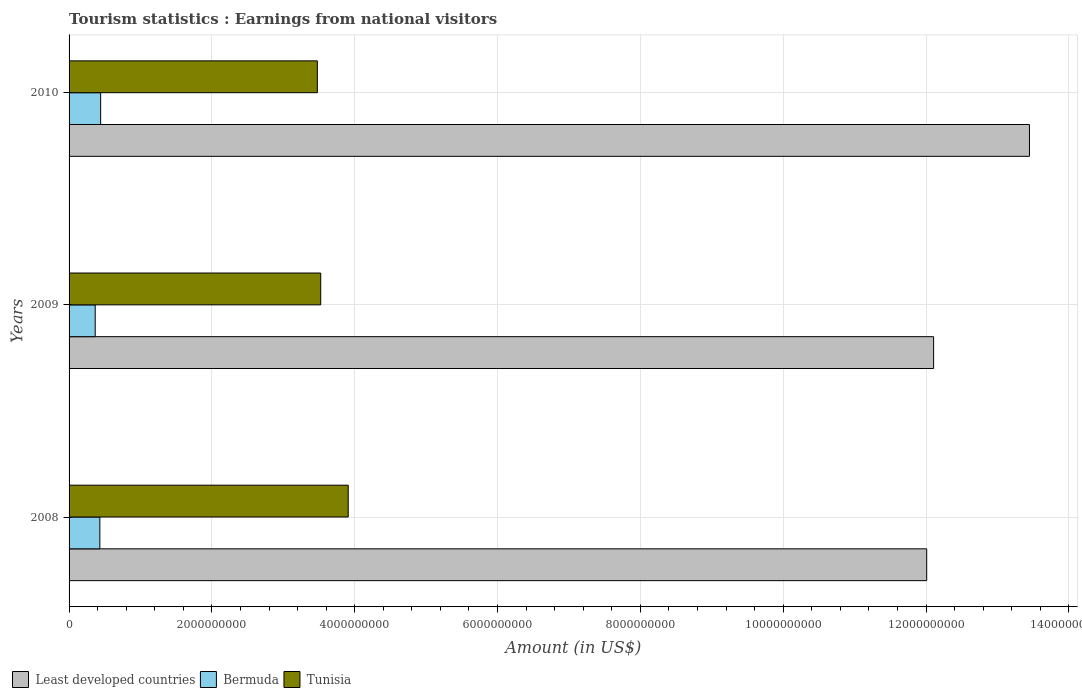What is the label of the 2nd group of bars from the top?
Your response must be concise. 2009. In how many cases, is the number of bars for a given year not equal to the number of legend labels?
Provide a short and direct response. 0. What is the earnings from national visitors in Tunisia in 2008?
Give a very brief answer. 3.91e+09. Across all years, what is the maximum earnings from national visitors in Bermuda?
Provide a succinct answer. 4.42e+08. Across all years, what is the minimum earnings from national visitors in Least developed countries?
Keep it short and to the point. 1.20e+1. In which year was the earnings from national visitors in Tunisia maximum?
Keep it short and to the point. 2008. In which year was the earnings from national visitors in Tunisia minimum?
Make the answer very short. 2010. What is the total earnings from national visitors in Bermuda in the graph?
Provide a short and direct response. 1.24e+09. What is the difference between the earnings from national visitors in Least developed countries in 2009 and that in 2010?
Give a very brief answer. -1.34e+09. What is the difference between the earnings from national visitors in Least developed countries in 2009 and the earnings from national visitors in Bermuda in 2008?
Offer a very short reply. 1.17e+1. What is the average earnings from national visitors in Bermuda per year?
Give a very brief answer. 4.13e+08. In the year 2008, what is the difference between the earnings from national visitors in Bermuda and earnings from national visitors in Least developed countries?
Keep it short and to the point. -1.16e+1. What is the ratio of the earnings from national visitors in Least developed countries in 2008 to that in 2010?
Offer a terse response. 0.89. Is the difference between the earnings from national visitors in Bermuda in 2008 and 2009 greater than the difference between the earnings from national visitors in Least developed countries in 2008 and 2009?
Keep it short and to the point. Yes. What is the difference between the highest and the second highest earnings from national visitors in Tunisia?
Make the answer very short. 3.85e+08. What is the difference between the highest and the lowest earnings from national visitors in Bermuda?
Your answer should be very brief. 7.60e+07. What does the 2nd bar from the top in 2009 represents?
Your answer should be very brief. Bermuda. What does the 2nd bar from the bottom in 2009 represents?
Your answer should be compact. Bermuda. Is it the case that in every year, the sum of the earnings from national visitors in Tunisia and earnings from national visitors in Bermuda is greater than the earnings from national visitors in Least developed countries?
Give a very brief answer. No. Are all the bars in the graph horizontal?
Your response must be concise. Yes. What is the difference between two consecutive major ticks on the X-axis?
Ensure brevity in your answer.  2.00e+09. Does the graph contain grids?
Offer a very short reply. Yes. How many legend labels are there?
Your answer should be very brief. 3. What is the title of the graph?
Provide a succinct answer. Tourism statistics : Earnings from national visitors. What is the label or title of the X-axis?
Give a very brief answer. Amount (in US$). What is the Amount (in US$) in Least developed countries in 2008?
Your response must be concise. 1.20e+1. What is the Amount (in US$) of Bermuda in 2008?
Your response must be concise. 4.31e+08. What is the Amount (in US$) of Tunisia in 2008?
Provide a short and direct response. 3.91e+09. What is the Amount (in US$) of Least developed countries in 2009?
Give a very brief answer. 1.21e+1. What is the Amount (in US$) of Bermuda in 2009?
Your answer should be compact. 3.66e+08. What is the Amount (in US$) of Tunisia in 2009?
Keep it short and to the point. 3.52e+09. What is the Amount (in US$) in Least developed countries in 2010?
Make the answer very short. 1.34e+1. What is the Amount (in US$) of Bermuda in 2010?
Offer a terse response. 4.42e+08. What is the Amount (in US$) in Tunisia in 2010?
Provide a succinct answer. 3.48e+09. Across all years, what is the maximum Amount (in US$) in Least developed countries?
Give a very brief answer. 1.34e+1. Across all years, what is the maximum Amount (in US$) in Bermuda?
Your response must be concise. 4.42e+08. Across all years, what is the maximum Amount (in US$) in Tunisia?
Provide a short and direct response. 3.91e+09. Across all years, what is the minimum Amount (in US$) of Least developed countries?
Ensure brevity in your answer.  1.20e+1. Across all years, what is the minimum Amount (in US$) in Bermuda?
Provide a succinct answer. 3.66e+08. Across all years, what is the minimum Amount (in US$) in Tunisia?
Offer a terse response. 3.48e+09. What is the total Amount (in US$) of Least developed countries in the graph?
Keep it short and to the point. 3.76e+1. What is the total Amount (in US$) in Bermuda in the graph?
Offer a very short reply. 1.24e+09. What is the total Amount (in US$) in Tunisia in the graph?
Provide a succinct answer. 1.09e+1. What is the difference between the Amount (in US$) of Least developed countries in 2008 and that in 2009?
Ensure brevity in your answer.  -9.67e+07. What is the difference between the Amount (in US$) of Bermuda in 2008 and that in 2009?
Provide a succinct answer. 6.50e+07. What is the difference between the Amount (in US$) of Tunisia in 2008 and that in 2009?
Provide a succinct answer. 3.85e+08. What is the difference between the Amount (in US$) of Least developed countries in 2008 and that in 2010?
Ensure brevity in your answer.  -1.44e+09. What is the difference between the Amount (in US$) of Bermuda in 2008 and that in 2010?
Your answer should be very brief. -1.10e+07. What is the difference between the Amount (in US$) of Tunisia in 2008 and that in 2010?
Offer a very short reply. 4.32e+08. What is the difference between the Amount (in US$) of Least developed countries in 2009 and that in 2010?
Your answer should be very brief. -1.34e+09. What is the difference between the Amount (in US$) in Bermuda in 2009 and that in 2010?
Provide a succinct answer. -7.60e+07. What is the difference between the Amount (in US$) of Tunisia in 2009 and that in 2010?
Ensure brevity in your answer.  4.70e+07. What is the difference between the Amount (in US$) of Least developed countries in 2008 and the Amount (in US$) of Bermuda in 2009?
Your answer should be very brief. 1.16e+1. What is the difference between the Amount (in US$) of Least developed countries in 2008 and the Amount (in US$) of Tunisia in 2009?
Offer a terse response. 8.49e+09. What is the difference between the Amount (in US$) of Bermuda in 2008 and the Amount (in US$) of Tunisia in 2009?
Provide a succinct answer. -3.09e+09. What is the difference between the Amount (in US$) in Least developed countries in 2008 and the Amount (in US$) in Bermuda in 2010?
Your answer should be compact. 1.16e+1. What is the difference between the Amount (in US$) of Least developed countries in 2008 and the Amount (in US$) of Tunisia in 2010?
Ensure brevity in your answer.  8.53e+09. What is the difference between the Amount (in US$) of Bermuda in 2008 and the Amount (in US$) of Tunisia in 2010?
Your answer should be compact. -3.05e+09. What is the difference between the Amount (in US$) in Least developed countries in 2009 and the Amount (in US$) in Bermuda in 2010?
Keep it short and to the point. 1.17e+1. What is the difference between the Amount (in US$) in Least developed countries in 2009 and the Amount (in US$) in Tunisia in 2010?
Your response must be concise. 8.63e+09. What is the difference between the Amount (in US$) in Bermuda in 2009 and the Amount (in US$) in Tunisia in 2010?
Offer a terse response. -3.11e+09. What is the average Amount (in US$) of Least developed countries per year?
Provide a short and direct response. 1.25e+1. What is the average Amount (in US$) in Bermuda per year?
Your answer should be very brief. 4.13e+08. What is the average Amount (in US$) in Tunisia per year?
Keep it short and to the point. 3.64e+09. In the year 2008, what is the difference between the Amount (in US$) of Least developed countries and Amount (in US$) of Bermuda?
Your answer should be compact. 1.16e+1. In the year 2008, what is the difference between the Amount (in US$) in Least developed countries and Amount (in US$) in Tunisia?
Make the answer very short. 8.10e+09. In the year 2008, what is the difference between the Amount (in US$) of Bermuda and Amount (in US$) of Tunisia?
Offer a very short reply. -3.48e+09. In the year 2009, what is the difference between the Amount (in US$) in Least developed countries and Amount (in US$) in Bermuda?
Keep it short and to the point. 1.17e+1. In the year 2009, what is the difference between the Amount (in US$) of Least developed countries and Amount (in US$) of Tunisia?
Make the answer very short. 8.58e+09. In the year 2009, what is the difference between the Amount (in US$) of Bermuda and Amount (in US$) of Tunisia?
Your response must be concise. -3.16e+09. In the year 2010, what is the difference between the Amount (in US$) in Least developed countries and Amount (in US$) in Bermuda?
Your answer should be compact. 1.30e+1. In the year 2010, what is the difference between the Amount (in US$) of Least developed countries and Amount (in US$) of Tunisia?
Make the answer very short. 9.97e+09. In the year 2010, what is the difference between the Amount (in US$) of Bermuda and Amount (in US$) of Tunisia?
Make the answer very short. -3.04e+09. What is the ratio of the Amount (in US$) in Bermuda in 2008 to that in 2009?
Ensure brevity in your answer.  1.18. What is the ratio of the Amount (in US$) of Tunisia in 2008 to that in 2009?
Your answer should be very brief. 1.11. What is the ratio of the Amount (in US$) in Least developed countries in 2008 to that in 2010?
Give a very brief answer. 0.89. What is the ratio of the Amount (in US$) of Bermuda in 2008 to that in 2010?
Make the answer very short. 0.98. What is the ratio of the Amount (in US$) in Tunisia in 2008 to that in 2010?
Make the answer very short. 1.12. What is the ratio of the Amount (in US$) of Least developed countries in 2009 to that in 2010?
Your answer should be compact. 0.9. What is the ratio of the Amount (in US$) in Bermuda in 2009 to that in 2010?
Provide a succinct answer. 0.83. What is the ratio of the Amount (in US$) of Tunisia in 2009 to that in 2010?
Your answer should be very brief. 1.01. What is the difference between the highest and the second highest Amount (in US$) in Least developed countries?
Offer a terse response. 1.34e+09. What is the difference between the highest and the second highest Amount (in US$) in Bermuda?
Give a very brief answer. 1.10e+07. What is the difference between the highest and the second highest Amount (in US$) of Tunisia?
Provide a short and direct response. 3.85e+08. What is the difference between the highest and the lowest Amount (in US$) of Least developed countries?
Your response must be concise. 1.44e+09. What is the difference between the highest and the lowest Amount (in US$) of Bermuda?
Provide a succinct answer. 7.60e+07. What is the difference between the highest and the lowest Amount (in US$) in Tunisia?
Make the answer very short. 4.32e+08. 